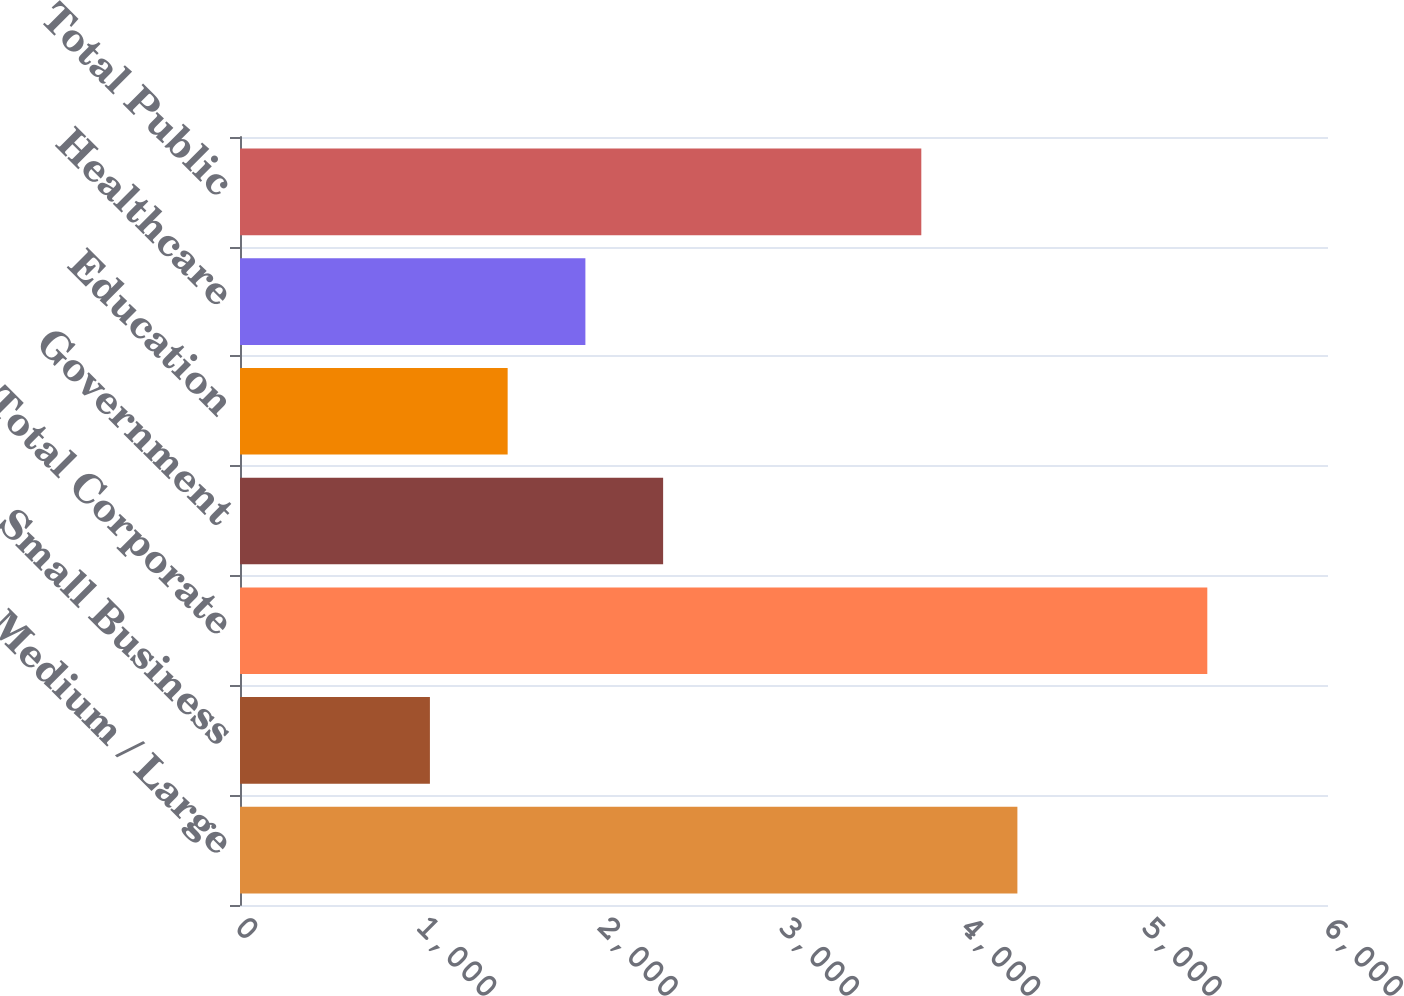Convert chart to OTSL. <chart><loc_0><loc_0><loc_500><loc_500><bar_chart><fcel>Medium / Large<fcel>Small Business<fcel>Total Corporate<fcel>Government<fcel>Education<fcel>Healthcare<fcel>Total Public<nl><fcel>4287.1<fcel>1047.3<fcel>5334.4<fcel>2333.43<fcel>1476.01<fcel>1904.72<fcel>3757.2<nl></chart> 